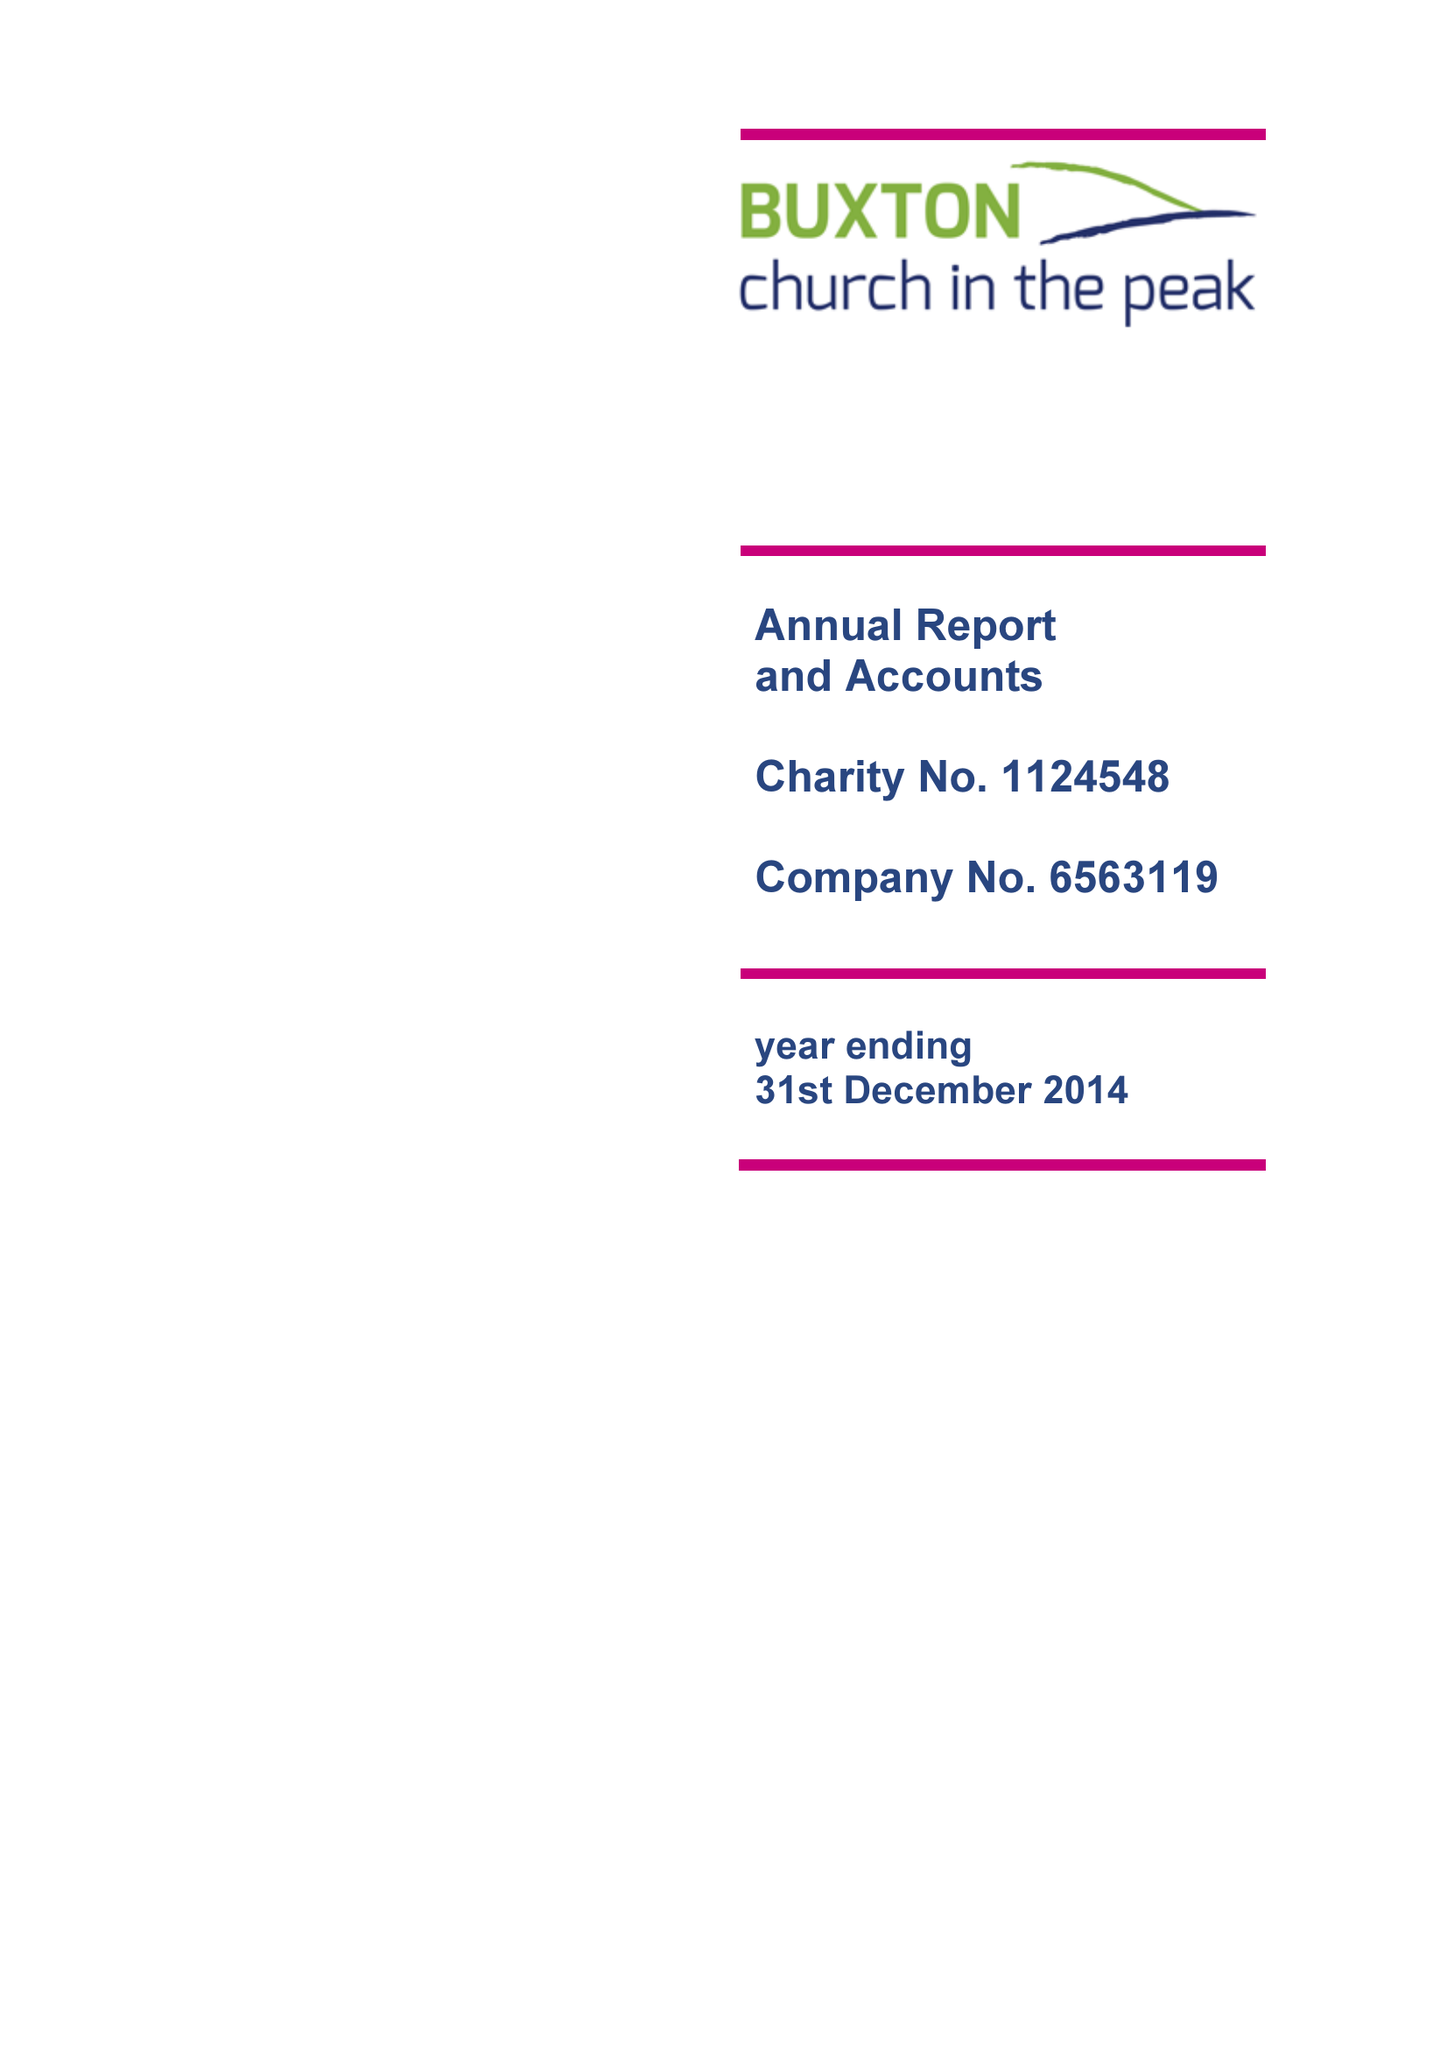What is the value for the charity_number?
Answer the question using a single word or phrase. 1124548 